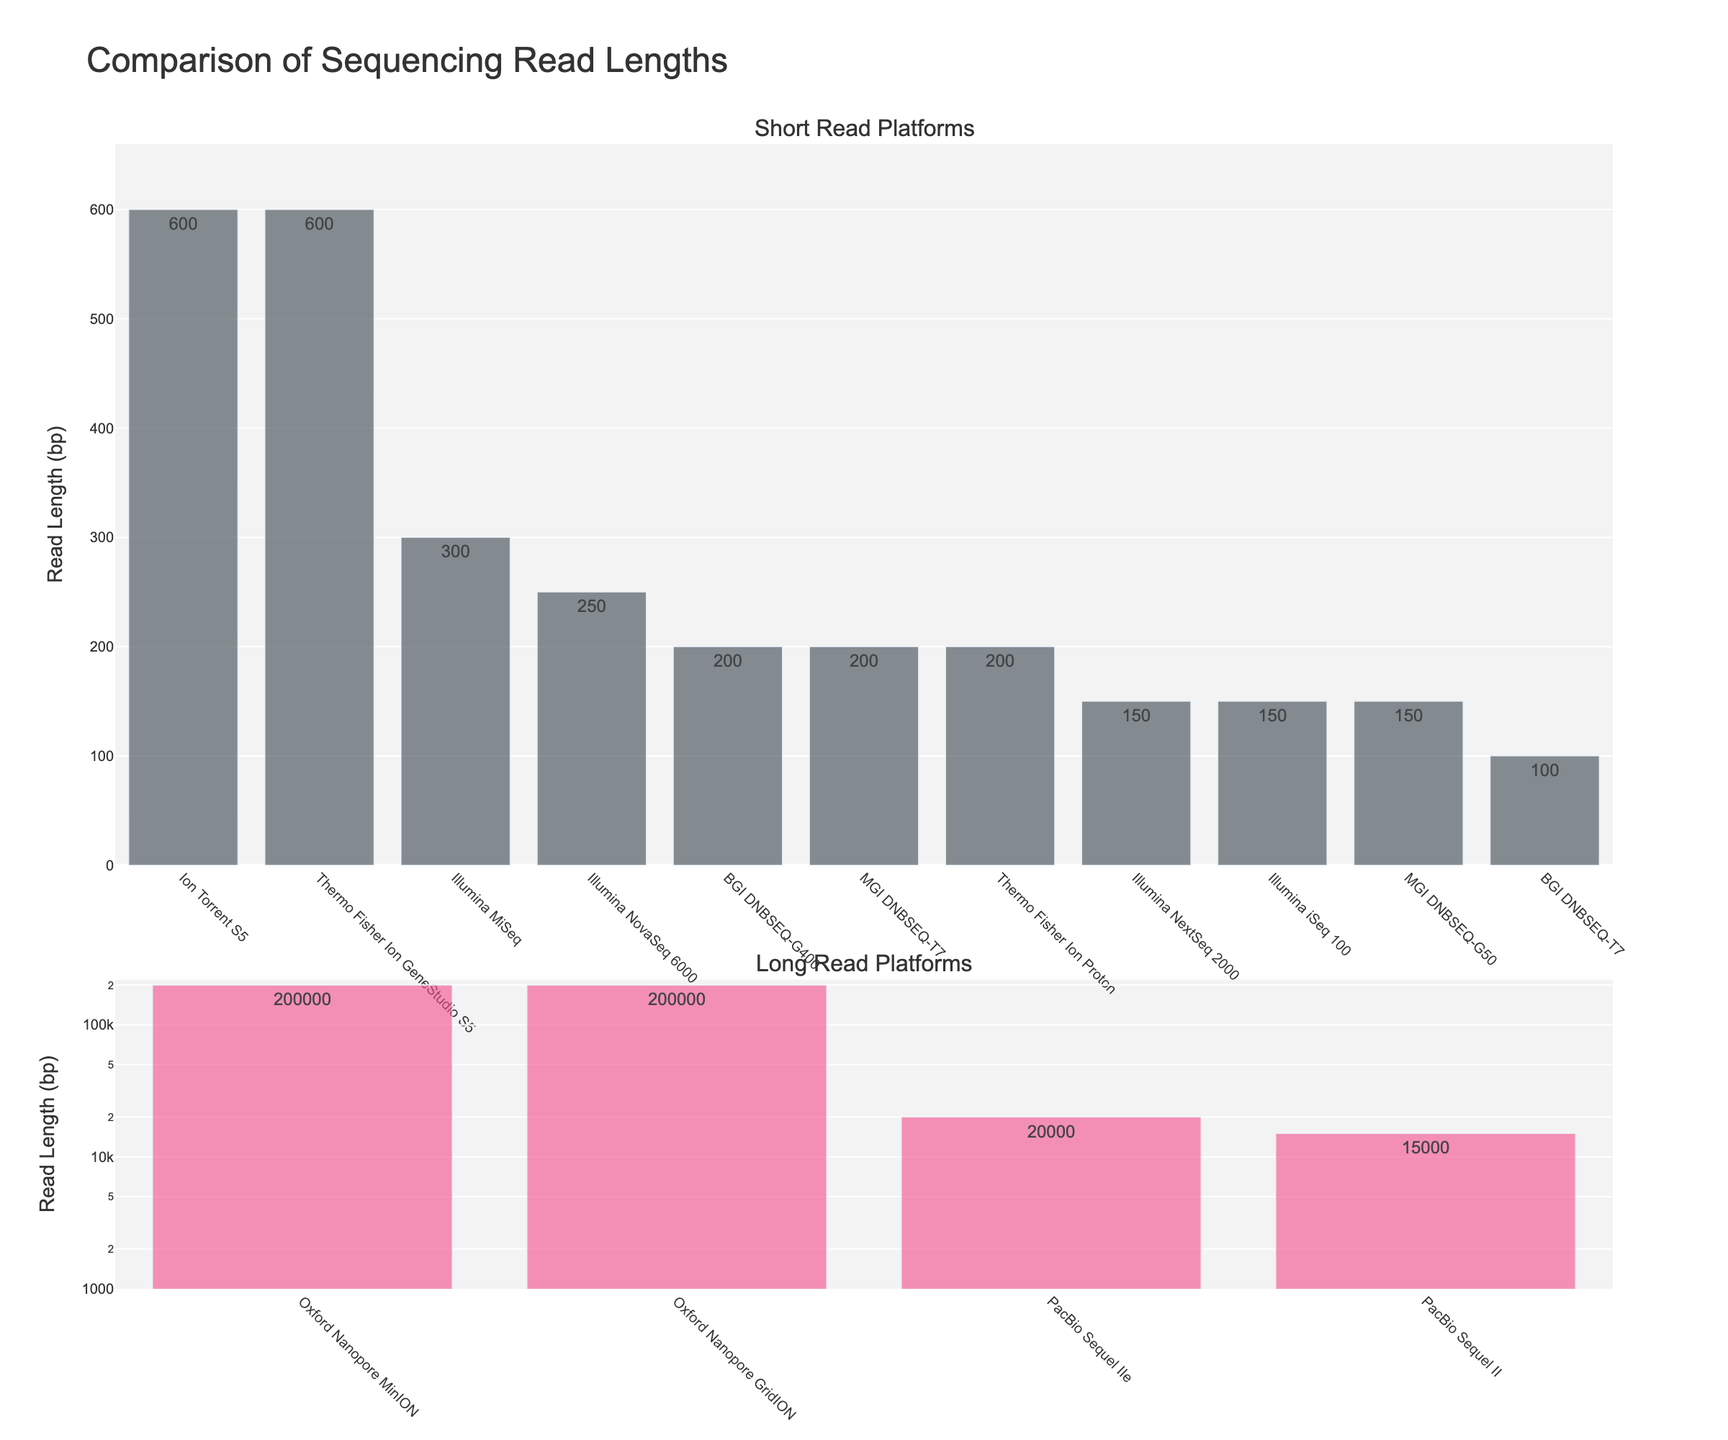Which platform has the highest read length? The longest bar in the "Long Read Platforms" subplot represents the platform with the highest read length, which is Oxford Nanopore GridION with 200,000 bp.
Answer: Oxford Nanopore GridION Which platform has the shortest read length? The smallest bar in the "Short Read Platforms" subplot represents the platform with the shortest read length, which is BGI DNBSEQ-T7 with 100 bp.
Answer: BGI DNBSEQ-T7 What is the combined read length of all Illumina platforms? Sum the read lengths of Illumina NovaSeq 6000 (250), Illumina MiSeq (300), Illumina NextSeq 2000 (150), and Illumina iSeq 100 (150). 250 + 300 + 150 + 150 = 850 bp.
Answer: 850 bp Compare the read length of PacBio Sequel II with Ion Torrent S5. The bar for PacBio Sequel II shows a read length of 15,000 bp, whereas Ion Torrent S5 has a read length of 600 bp. 15,000 bp is significantly longer than 600 bp.
Answer: PacBio Sequel II What is the difference in read length between Oxford Nanopore MinION and PacBio Sequel IIe? Oxford Nanopore MinION has a read length of 200,000 bp, and PacBio Sequel IIe has a read length of 20,000 bp. The difference is 200,000 - 20,000 = 180,000 bp.
Answer: 180,000 bp What is the average read length of the "Short Read Platforms"? Sum the read lengths of all platforms in the short read subplot and divide by the number of platforms: (250 + 300 + 600 + 200 + 200 + 150 + 600 + 100 + 150 + 200 + 150) / 11 = 275 bp.
Answer: 275 bp Which platform has a read length closest to the overall average of all platforms? First, calculate the overall average: sum all read lengths and divide by the number of platforms. (250 + 300 + 600 + 200 + 200000 + 15000 + 200 + 150 + 600 + 100 + 200000 + 20000 + 150 + 200 + 150) / 15 = 29,256 bp. The platform closest to this average is PacBio Sequel IIe with 20,000 bp.
Answer: PacBio Sequel IIe Which has longer reads, Thermo Fisher Ion Proton or MGI DNBSEQ-G50? Thermo Fisher Ion Proton has a read length of 200 bp, whereas MGI DNBSEQ-G50 has a read length of 150 bp. Thermo Fisher Ion Proton has longer reads.
Answer: Thermo Fisher Ion Proton Which subgroup has more platforms, Short Read Platforms or Long Read Platforms? Count the bars in each subplot: Short Read Platforms have 11 platforms, while Long Read Platforms have 4 platforms. Short Read Platforms have more platforms.
Answer: Short Read Platforms 